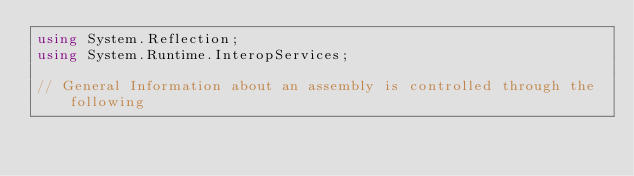Convert code to text. <code><loc_0><loc_0><loc_500><loc_500><_C#_>using System.Reflection;
using System.Runtime.InteropServices;

// General Information about an assembly is controlled through the following </code> 